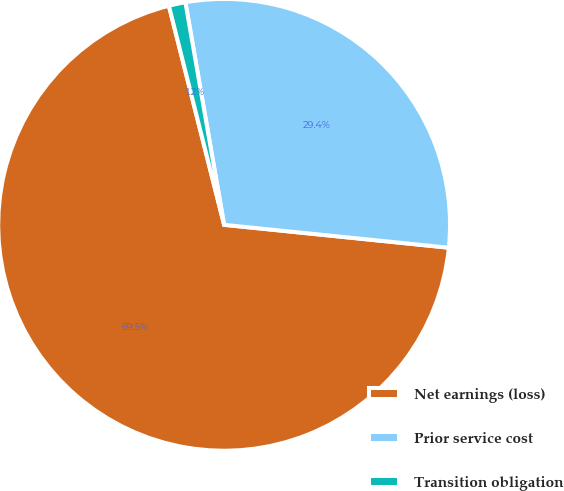<chart> <loc_0><loc_0><loc_500><loc_500><pie_chart><fcel>Net earnings (loss)<fcel>Prior service cost<fcel>Transition obligation<nl><fcel>69.46%<fcel>29.36%<fcel>1.19%<nl></chart> 